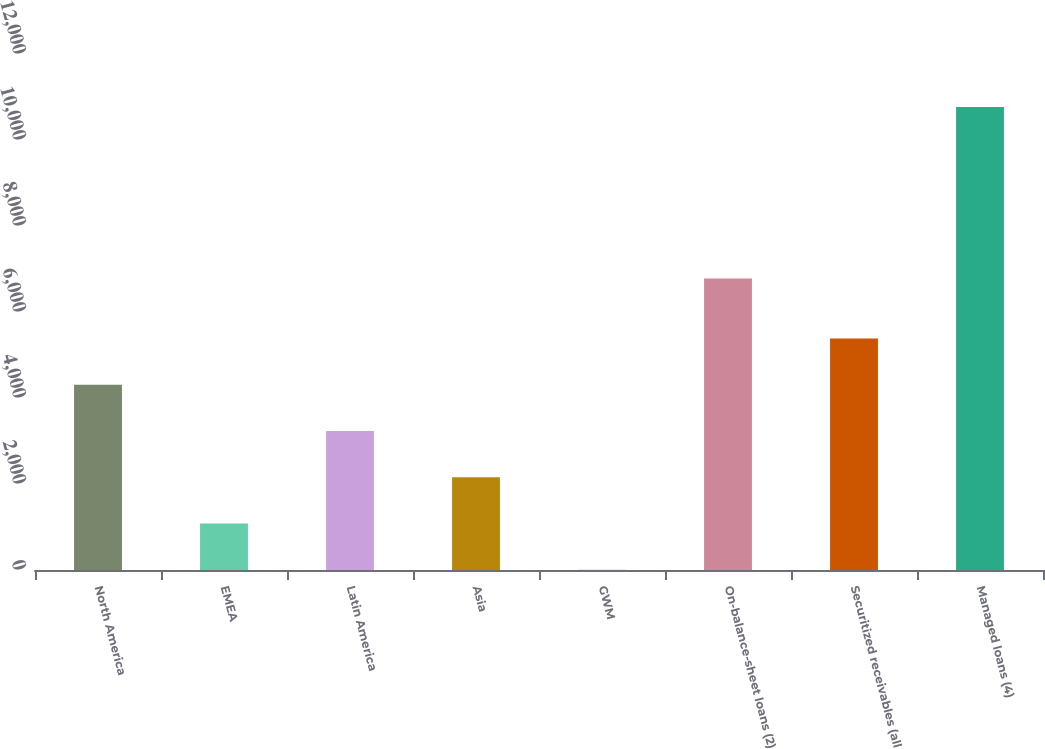Convert chart to OTSL. <chart><loc_0><loc_0><loc_500><loc_500><bar_chart><fcel>North America<fcel>EMEA<fcel>Latin America<fcel>Asia<fcel>GWM<fcel>On-balance-sheet loans (2)<fcel>Securitized receivables (all<fcel>Managed loans (4)<nl><fcel>4310<fcel>1080.5<fcel>3233.5<fcel>2157<fcel>4<fcel>6778<fcel>5386.5<fcel>10769<nl></chart> 